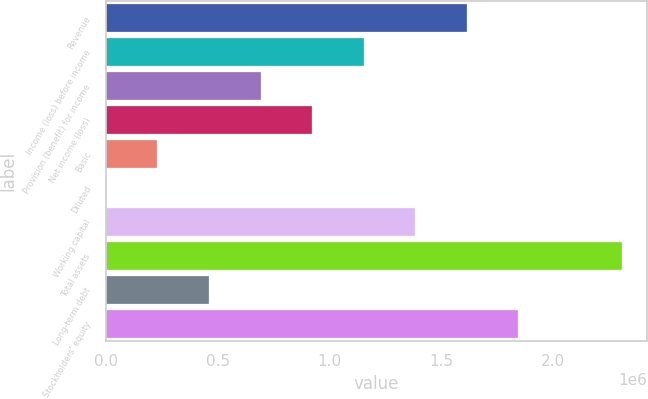<chart> <loc_0><loc_0><loc_500><loc_500><bar_chart><fcel>Revenue<fcel>Income (loss) before income<fcel>Provision (benefit) for income<fcel>Net income (loss)<fcel>Basic<fcel>Diluted<fcel>Working capital<fcel>Total assets<fcel>Long-term debt<fcel>Stockholders' equity<nl><fcel>1.61515e+06<fcel>1.15368e+06<fcel>692207<fcel>922942<fcel>230736<fcel>0.95<fcel>1.38441e+06<fcel>2.30735e+06<fcel>461471<fcel>1.84588e+06<nl></chart> 